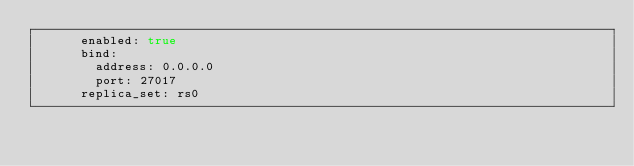<code> <loc_0><loc_0><loc_500><loc_500><_YAML_>      enabled: true
      bind:
        address: 0.0.0.0
        port: 27017
      replica_set: rs0
</code> 